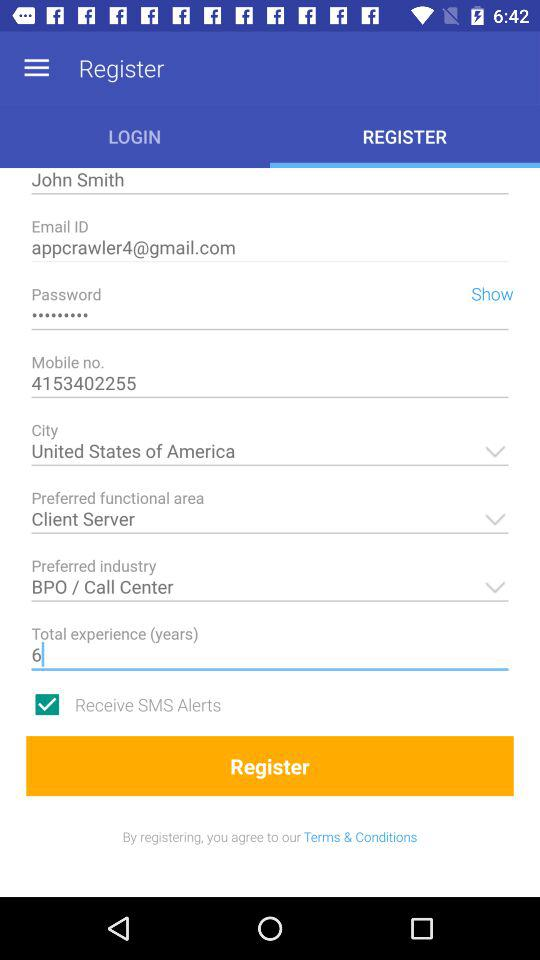What is the mobile number? The mobile number is 4153402255. 